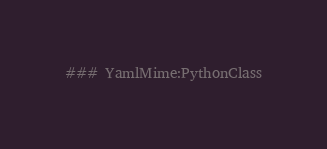Convert code to text. <code><loc_0><loc_0><loc_500><loc_500><_YAML_>### YamlMime:PythonClass</code> 